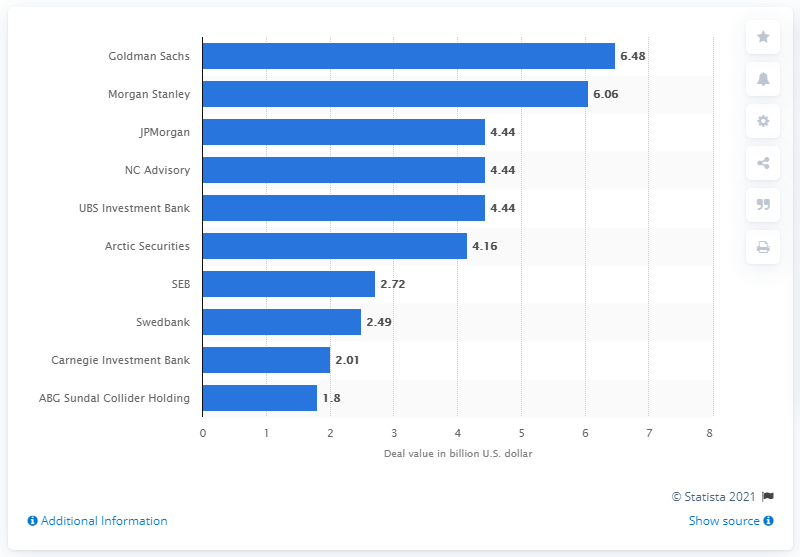Identify some key points in this picture. In 2016, Goldman Sachs was the leading advisor to M&A deals in Norway. In 2016, the deal value of Goldman Sachs was approximately 6.48 billion. 